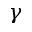<formula> <loc_0><loc_0><loc_500><loc_500>\gamma</formula> 